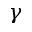<formula> <loc_0><loc_0><loc_500><loc_500>\gamma</formula> 